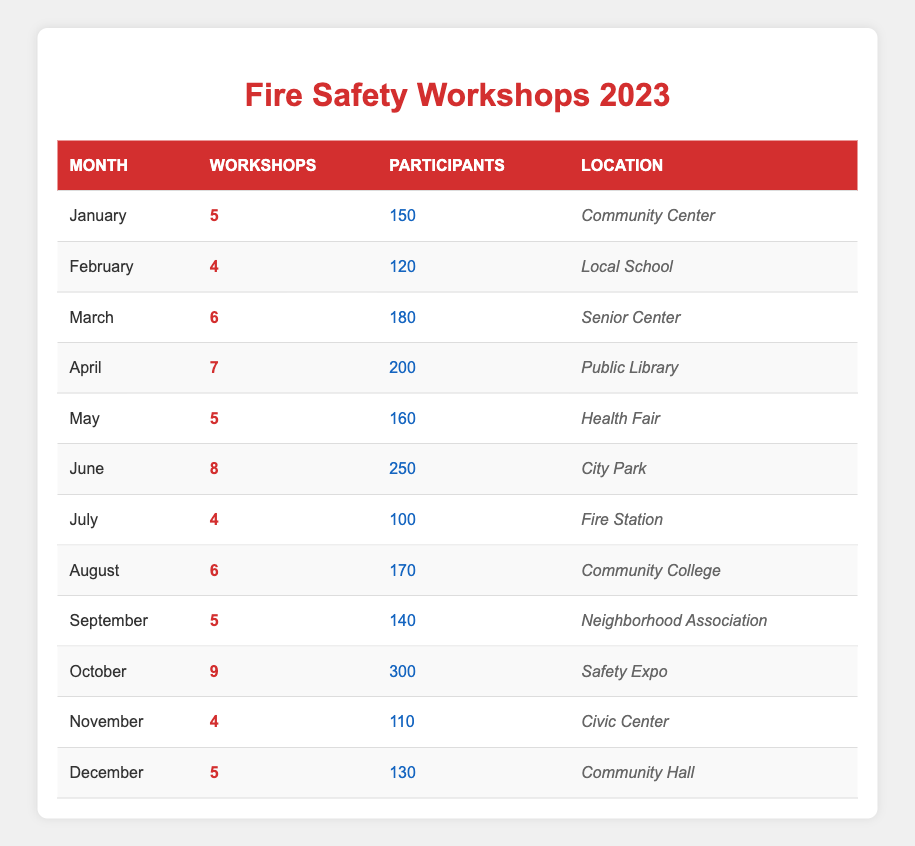What's the total number of fire safety workshops conducted in 2023? To find the total number of workshops, I need to sum the values in the "Workshops" column: 5 + 4 + 6 + 7 + 5 + 8 + 4 + 6 + 5 + 9 + 4 + 5 =  63
Answer: 63 Which month had the highest number of participants? Looking through the "Participants" column, I note the highest value is 300 in October.
Answer: October Did more workshops take place in the first half of the year compared to the second half? First half total: January (5) + February (4) + March (6) + April (7) + May (5) + June (8) = 35. Second half total: July (4) + August (6) + September (5) + October (9) + November (4) + December (5) = 33. Since 35 is greater than 33, more workshops were held in the first half.
Answer: Yes What is the average number of participants per workshop for the year? To find the average, I first sum the participants: 150 + 120 + 180 + 200 + 160 + 250 + 100 + 170 + 140 + 300 + 110 + 130 = 1860. Then, I divide by the total workshops (63): 1860 / 63 ≈ 29.52 participants per workshop.
Answer: Approximately 29.52 Is there a month where the number of workshops conducted was equal to the number of participants? I can check each month's "Workshops" and "Participants" values. No month shows an equal number between the two columns.
Answer: No 